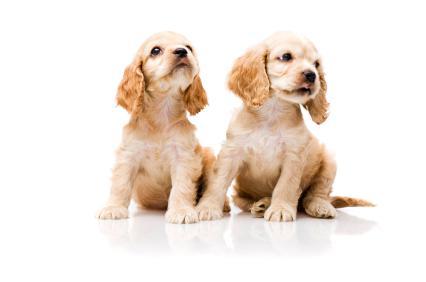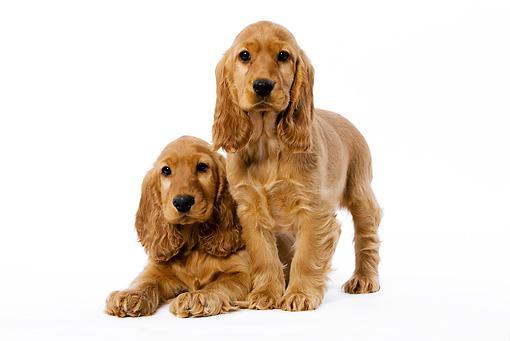The first image is the image on the left, the second image is the image on the right. Considering the images on both sides, is "There are a total of 4 dogs present." valid? Answer yes or no. Yes. The first image is the image on the left, the second image is the image on the right. For the images displayed, is the sentence "there are 3 dogs in the image pair" factually correct? Answer yes or no. No. 